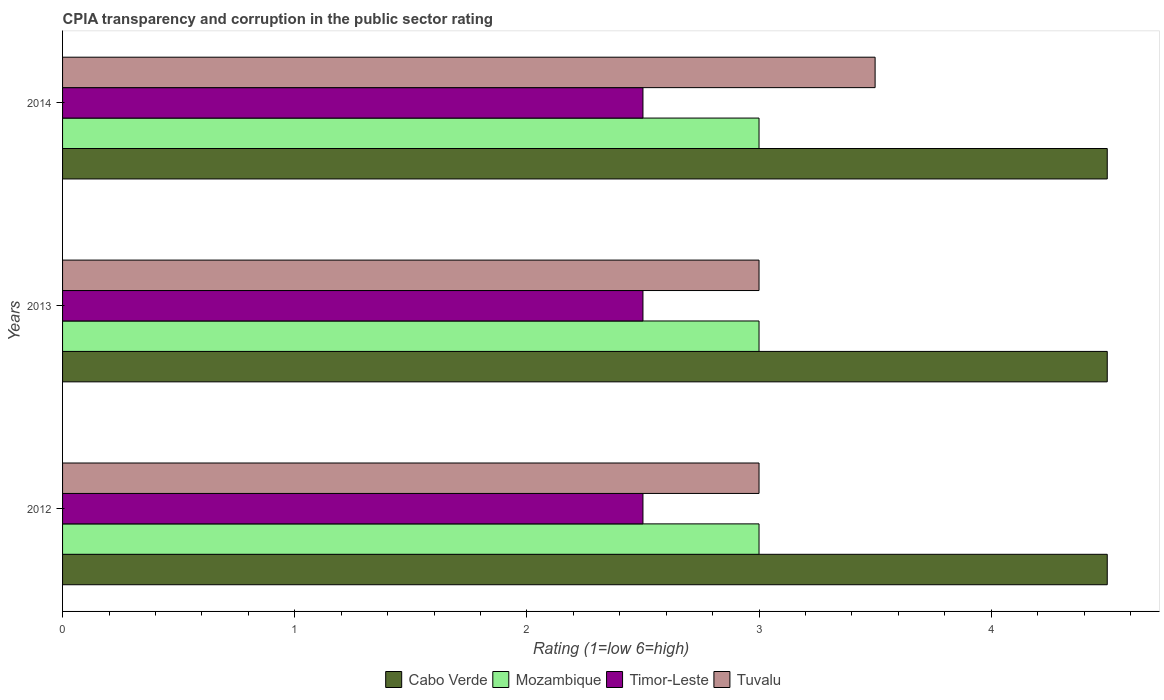How many groups of bars are there?
Your response must be concise. 3. Are the number of bars per tick equal to the number of legend labels?
Provide a short and direct response. Yes. What is the CPIA rating in Mozambique in 2014?
Provide a short and direct response. 3. Across all years, what is the minimum CPIA rating in Tuvalu?
Provide a succinct answer. 3. What is the total CPIA rating in Tuvalu in the graph?
Offer a very short reply. 9.5. What is the difference between the CPIA rating in Mozambique in 2012 and that in 2013?
Ensure brevity in your answer.  0. What is the difference between the CPIA rating in Mozambique in 2013 and the CPIA rating in Tuvalu in 2012?
Offer a terse response. 0. What is the average CPIA rating in Tuvalu per year?
Your answer should be very brief. 3.17. In the year 2014, what is the difference between the CPIA rating in Timor-Leste and CPIA rating in Tuvalu?
Keep it short and to the point. -1. In how many years, is the CPIA rating in Cabo Verde greater than 2 ?
Your answer should be compact. 3. What is the ratio of the CPIA rating in Mozambique in 2012 to that in 2013?
Keep it short and to the point. 1. What is the difference between the highest and the second highest CPIA rating in Mozambique?
Your response must be concise. 0. In how many years, is the CPIA rating in Timor-Leste greater than the average CPIA rating in Timor-Leste taken over all years?
Your answer should be very brief. 0. What does the 2nd bar from the top in 2014 represents?
Provide a succinct answer. Timor-Leste. What does the 1st bar from the bottom in 2012 represents?
Your answer should be very brief. Cabo Verde. What is the difference between two consecutive major ticks on the X-axis?
Provide a short and direct response. 1. Are the values on the major ticks of X-axis written in scientific E-notation?
Your answer should be very brief. No. Does the graph contain grids?
Offer a terse response. No. Where does the legend appear in the graph?
Provide a succinct answer. Bottom center. How many legend labels are there?
Keep it short and to the point. 4. How are the legend labels stacked?
Provide a succinct answer. Horizontal. What is the title of the graph?
Your answer should be compact. CPIA transparency and corruption in the public sector rating. Does "Somalia" appear as one of the legend labels in the graph?
Your response must be concise. No. What is the label or title of the X-axis?
Your answer should be very brief. Rating (1=low 6=high). What is the label or title of the Y-axis?
Your answer should be compact. Years. What is the Rating (1=low 6=high) of Cabo Verde in 2012?
Your answer should be very brief. 4.5. What is the Rating (1=low 6=high) in Timor-Leste in 2012?
Keep it short and to the point. 2.5. What is the Rating (1=low 6=high) in Cabo Verde in 2013?
Give a very brief answer. 4.5. What is the Rating (1=low 6=high) of Timor-Leste in 2013?
Make the answer very short. 2.5. What is the Rating (1=low 6=high) of Tuvalu in 2013?
Keep it short and to the point. 3. What is the Rating (1=low 6=high) of Mozambique in 2014?
Your response must be concise. 3. What is the Rating (1=low 6=high) of Timor-Leste in 2014?
Offer a very short reply. 2.5. What is the Rating (1=low 6=high) of Tuvalu in 2014?
Keep it short and to the point. 3.5. Across all years, what is the maximum Rating (1=low 6=high) of Mozambique?
Your answer should be compact. 3. Across all years, what is the maximum Rating (1=low 6=high) of Timor-Leste?
Your response must be concise. 2.5. Across all years, what is the minimum Rating (1=low 6=high) of Timor-Leste?
Offer a very short reply. 2.5. Across all years, what is the minimum Rating (1=low 6=high) of Tuvalu?
Provide a short and direct response. 3. What is the total Rating (1=low 6=high) in Mozambique in the graph?
Ensure brevity in your answer.  9. What is the total Rating (1=low 6=high) of Tuvalu in the graph?
Offer a very short reply. 9.5. What is the difference between the Rating (1=low 6=high) in Cabo Verde in 2012 and that in 2013?
Give a very brief answer. 0. What is the difference between the Rating (1=low 6=high) of Timor-Leste in 2012 and that in 2013?
Ensure brevity in your answer.  0. What is the difference between the Rating (1=low 6=high) of Tuvalu in 2012 and that in 2013?
Your response must be concise. 0. What is the difference between the Rating (1=low 6=high) in Tuvalu in 2012 and that in 2014?
Your response must be concise. -0.5. What is the difference between the Rating (1=low 6=high) of Cabo Verde in 2012 and the Rating (1=low 6=high) of Mozambique in 2013?
Keep it short and to the point. 1.5. What is the difference between the Rating (1=low 6=high) in Cabo Verde in 2012 and the Rating (1=low 6=high) in Timor-Leste in 2013?
Ensure brevity in your answer.  2. What is the difference between the Rating (1=low 6=high) of Mozambique in 2012 and the Rating (1=low 6=high) of Timor-Leste in 2013?
Provide a short and direct response. 0.5. What is the difference between the Rating (1=low 6=high) of Cabo Verde in 2012 and the Rating (1=low 6=high) of Mozambique in 2014?
Keep it short and to the point. 1.5. What is the difference between the Rating (1=low 6=high) in Mozambique in 2012 and the Rating (1=low 6=high) in Tuvalu in 2014?
Your response must be concise. -0.5. What is the difference between the Rating (1=low 6=high) in Cabo Verde in 2013 and the Rating (1=low 6=high) in Timor-Leste in 2014?
Keep it short and to the point. 2. What is the difference between the Rating (1=low 6=high) of Mozambique in 2013 and the Rating (1=low 6=high) of Tuvalu in 2014?
Your response must be concise. -0.5. What is the average Rating (1=low 6=high) of Mozambique per year?
Provide a short and direct response. 3. What is the average Rating (1=low 6=high) of Tuvalu per year?
Offer a terse response. 3.17. In the year 2012, what is the difference between the Rating (1=low 6=high) in Cabo Verde and Rating (1=low 6=high) in Timor-Leste?
Your response must be concise. 2. In the year 2012, what is the difference between the Rating (1=low 6=high) of Cabo Verde and Rating (1=low 6=high) of Tuvalu?
Your response must be concise. 1.5. In the year 2012, what is the difference between the Rating (1=low 6=high) in Mozambique and Rating (1=low 6=high) in Tuvalu?
Your answer should be compact. 0. In the year 2012, what is the difference between the Rating (1=low 6=high) in Timor-Leste and Rating (1=low 6=high) in Tuvalu?
Give a very brief answer. -0.5. In the year 2013, what is the difference between the Rating (1=low 6=high) in Cabo Verde and Rating (1=low 6=high) in Mozambique?
Give a very brief answer. 1.5. In the year 2014, what is the difference between the Rating (1=low 6=high) in Cabo Verde and Rating (1=low 6=high) in Timor-Leste?
Offer a very short reply. 2. In the year 2014, what is the difference between the Rating (1=low 6=high) in Mozambique and Rating (1=low 6=high) in Timor-Leste?
Make the answer very short. 0.5. What is the ratio of the Rating (1=low 6=high) in Timor-Leste in 2012 to that in 2013?
Keep it short and to the point. 1. What is the ratio of the Rating (1=low 6=high) of Timor-Leste in 2012 to that in 2014?
Keep it short and to the point. 1. What is the ratio of the Rating (1=low 6=high) in Tuvalu in 2012 to that in 2014?
Ensure brevity in your answer.  0.86. What is the ratio of the Rating (1=low 6=high) of Tuvalu in 2013 to that in 2014?
Provide a succinct answer. 0.86. What is the difference between the highest and the second highest Rating (1=low 6=high) in Mozambique?
Give a very brief answer. 0. What is the difference between the highest and the second highest Rating (1=low 6=high) of Timor-Leste?
Ensure brevity in your answer.  0. What is the difference between the highest and the lowest Rating (1=low 6=high) of Cabo Verde?
Offer a terse response. 0. What is the difference between the highest and the lowest Rating (1=low 6=high) of Timor-Leste?
Your answer should be very brief. 0. What is the difference between the highest and the lowest Rating (1=low 6=high) of Tuvalu?
Provide a short and direct response. 0.5. 